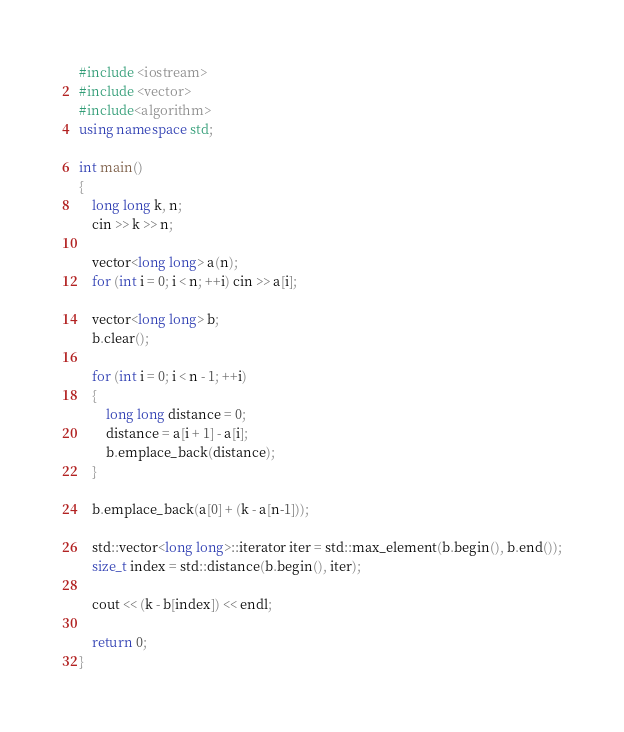<code> <loc_0><loc_0><loc_500><loc_500><_C++_>#include <iostream>
#include <vector>
#include<algorithm>
using namespace std;

int main()
{
	long long k, n;
	cin >> k >> n;

	vector<long long> a(n);
	for (int i = 0; i < n; ++i) cin >> a[i];

	vector<long long> b;
	b.clear();

	for (int i = 0; i < n - 1; ++i)
	{
		long long distance = 0;
		distance = a[i + 1] - a[i];
		b.emplace_back(distance);
	}

	b.emplace_back(a[0] + (k - a[n-1]));

	std::vector<long long>::iterator iter = std::max_element(b.begin(), b.end());
	size_t index = std::distance(b.begin(), iter);

	cout << (k - b[index]) << endl;

	return 0;
}
</code> 